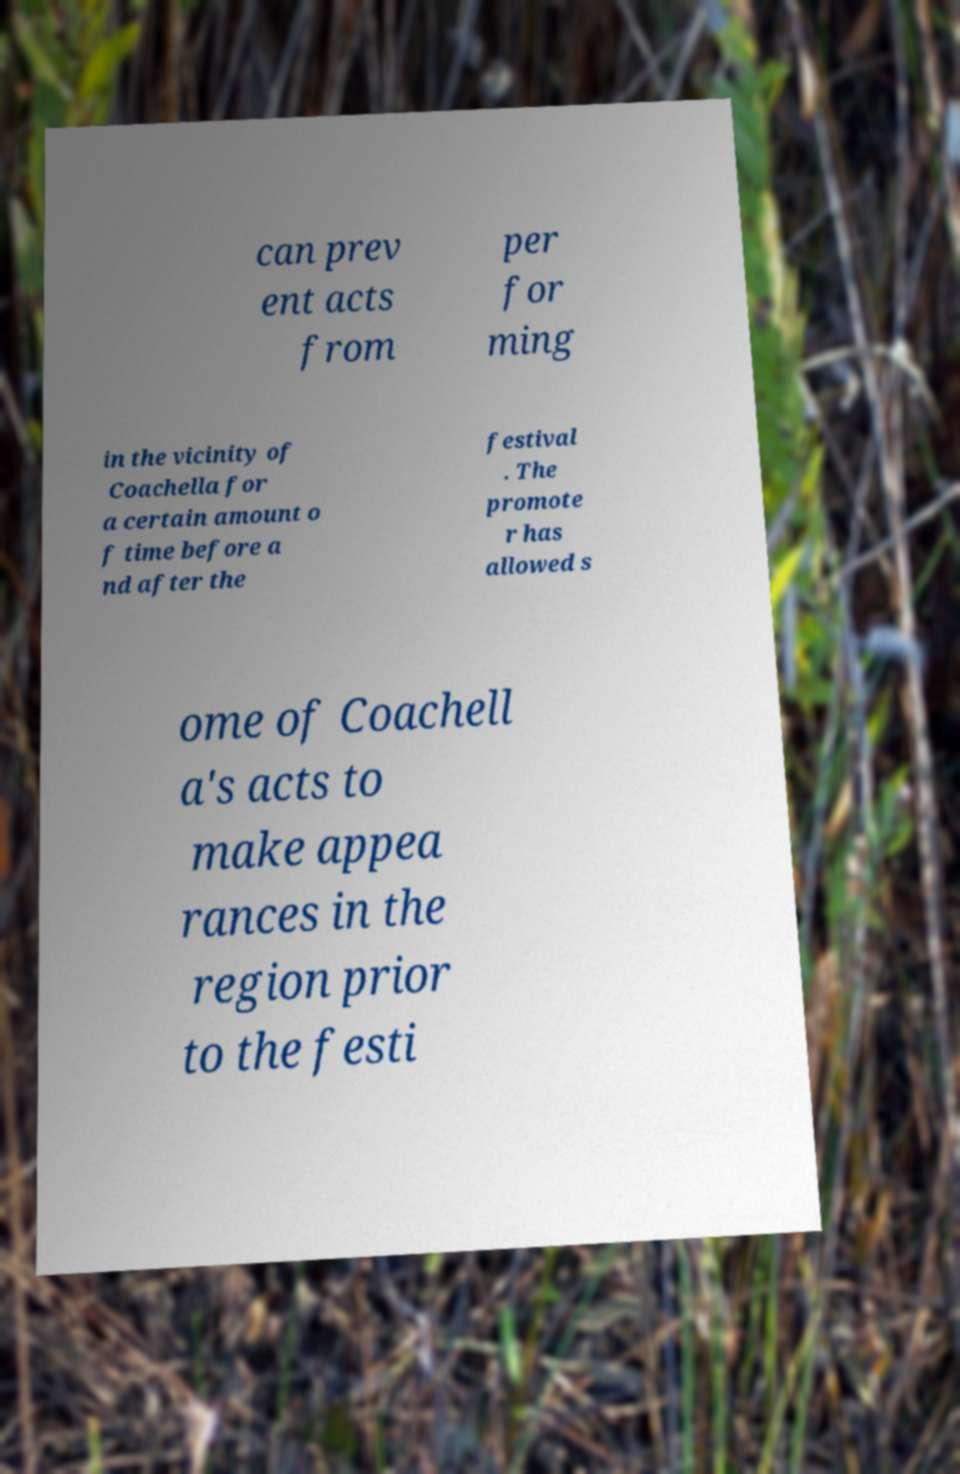Could you extract and type out the text from this image? can prev ent acts from per for ming in the vicinity of Coachella for a certain amount o f time before a nd after the festival . The promote r has allowed s ome of Coachell a's acts to make appea rances in the region prior to the festi 